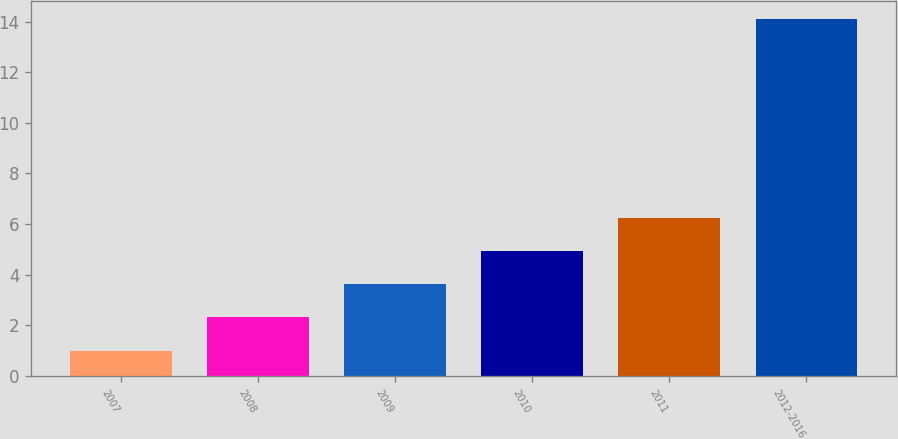Convert chart to OTSL. <chart><loc_0><loc_0><loc_500><loc_500><bar_chart><fcel>2007<fcel>2008<fcel>2009<fcel>2010<fcel>2011<fcel>2012-2016<nl><fcel>1<fcel>2.31<fcel>3.62<fcel>4.93<fcel>6.24<fcel>14.1<nl></chart> 